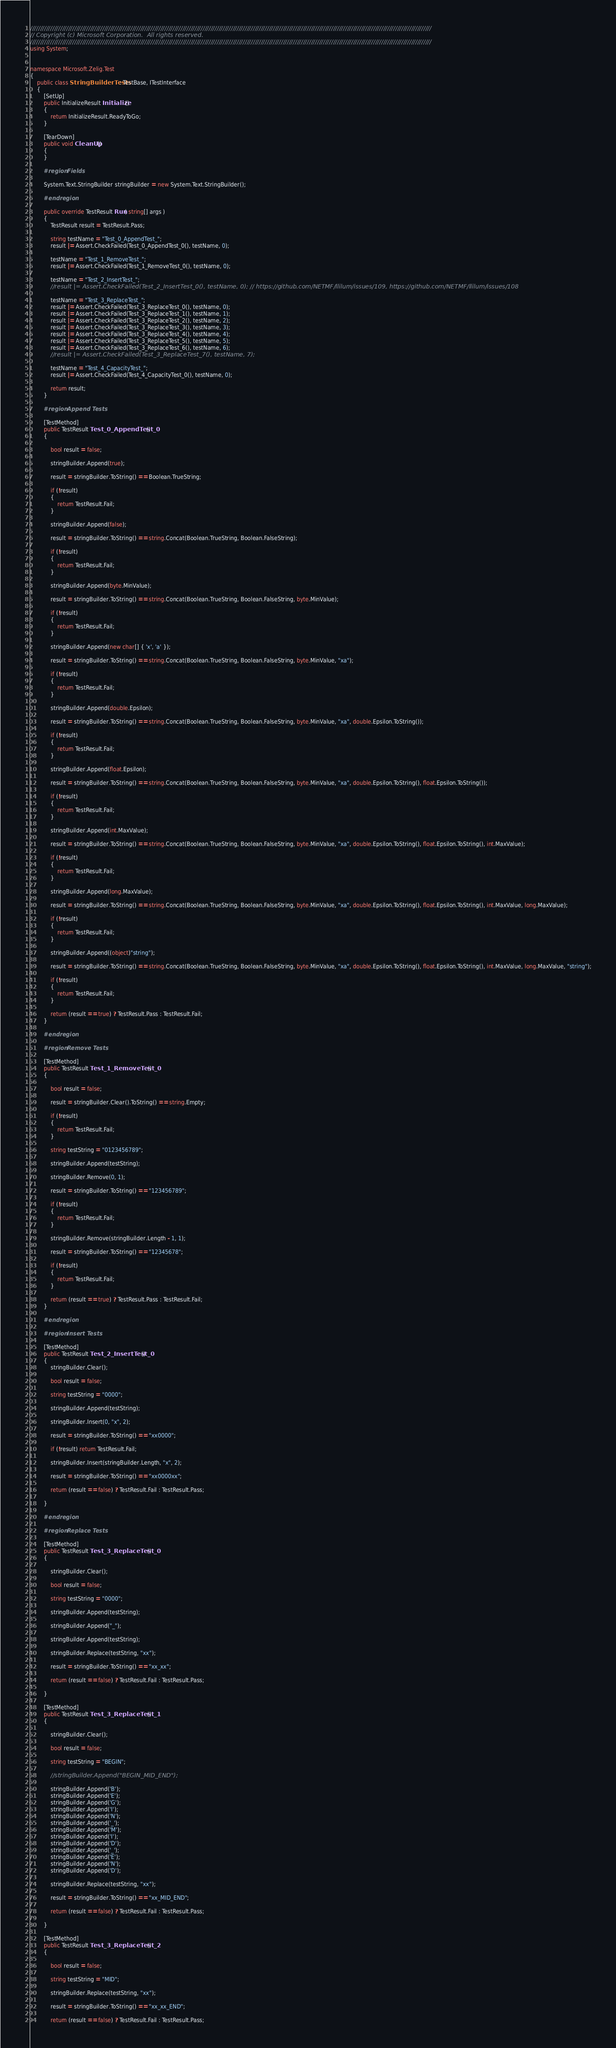<code> <loc_0><loc_0><loc_500><loc_500><_C#_>////////////////////////////////////////////////////////////////////////////////////////////////////////////////////////////////////////////////////////////////////////////////////////////////////////
// Copyright (c) Microsoft Corporation.  All rights reserved.
////////////////////////////////////////////////////////////////////////////////////////////////////////////////////////////////////////////////////////////////////////////////////////////////////////
using System;


namespace Microsoft.Zelig.Test
{
    public class StringBuilderTests : TestBase, ITestInterface
    {
        [SetUp]
        public InitializeResult Initialize()
        {
            return InitializeResult.ReadyToGo;                
        }

        [TearDown]
        public void CleanUp()
        {
        }

        #region Fields

        System.Text.StringBuilder stringBuilder = new System.Text.StringBuilder();

        #endregion

        public override TestResult Run( string[] args )
        {
            TestResult result = TestResult.Pass;

            string testName = "Test_0_AppendTest_";
            result |= Assert.CheckFailed(Test_0_AppendTest_0(), testName, 0);

            testName = "Test_1_RemoveTest_";
            result |= Assert.CheckFailed(Test_1_RemoveTest_0(), testName, 0);

            testName = "Test_2_InsertTest_";
            //result |= Assert.CheckFailed(Test_2_InsertTest_0(), testName, 0); // https://github.com/NETMF/llilum/issues/109, https://github.com/NETMF/llilum/issues/108

            testName = "Test_3_ReplaceTest_";
            result |= Assert.CheckFailed(Test_3_ReplaceTest_0(), testName, 0);
            result |= Assert.CheckFailed(Test_3_ReplaceTest_1(), testName, 1);
            result |= Assert.CheckFailed(Test_3_ReplaceTest_2(), testName, 2);
            result |= Assert.CheckFailed(Test_3_ReplaceTest_3(), testName, 3);
            result |= Assert.CheckFailed(Test_3_ReplaceTest_4(), testName, 4);
            result |= Assert.CheckFailed(Test_3_ReplaceTest_5(), testName, 5);
            result |= Assert.CheckFailed(Test_3_ReplaceTest_6(), testName, 6);
            //result |= Assert.CheckFailed(Test_3_ReplaceTest_7(), testName, 7);

            testName = "Test_4_CapacityTest_";
            result |= Assert.CheckFailed(Test_4_CapacityTest_0(), testName, 0);

            return result;
        }

        #region Append Tests
        
        [TestMethod]
        public TestResult Test_0_AppendTest_0()
        {

            bool result = false;

            stringBuilder.Append(true);

            result = stringBuilder.ToString() == Boolean.TrueString;

            if (!result)
            {
                return TestResult.Fail;
            }

            stringBuilder.Append(false);

            result = stringBuilder.ToString() == string.Concat(Boolean.TrueString, Boolean.FalseString);

            if (!result)
            {
                return TestResult.Fail;
            }

            stringBuilder.Append(byte.MinValue);

            result = stringBuilder.ToString() == string.Concat(Boolean.TrueString, Boolean.FalseString, byte.MinValue);

            if (!result)
            {
                return TestResult.Fail;
            }

            stringBuilder.Append(new char[] { 'x', 'a' });

            result = stringBuilder.ToString() == string.Concat(Boolean.TrueString, Boolean.FalseString, byte.MinValue, "xa");

            if (!result)
            {
                return TestResult.Fail;
            }

            stringBuilder.Append(double.Epsilon);

            result = stringBuilder.ToString() == string.Concat(Boolean.TrueString, Boolean.FalseString, byte.MinValue, "xa", double.Epsilon.ToString());

            if (!result)
            {
                return TestResult.Fail;
            }

            stringBuilder.Append(float.Epsilon);

            result = stringBuilder.ToString() == string.Concat(Boolean.TrueString, Boolean.FalseString, byte.MinValue, "xa", double.Epsilon.ToString(), float.Epsilon.ToString());

            if (!result)
            {
                return TestResult.Fail;
            }

            stringBuilder.Append(int.MaxValue);

            result = stringBuilder.ToString() == string.Concat(Boolean.TrueString, Boolean.FalseString, byte.MinValue, "xa", double.Epsilon.ToString(), float.Epsilon.ToString(), int.MaxValue);

            if (!result)
            {
                return TestResult.Fail;
            }

            stringBuilder.Append(long.MaxValue);

            result = stringBuilder.ToString() == string.Concat(Boolean.TrueString, Boolean.FalseString, byte.MinValue, "xa", double.Epsilon.ToString(), float.Epsilon.ToString(), int.MaxValue, long.MaxValue);

            if (!result)
            {
                return TestResult.Fail;
            }

            stringBuilder.Append((object)"string");

            result = stringBuilder.ToString() == string.Concat(Boolean.TrueString, Boolean.FalseString, byte.MinValue, "xa", double.Epsilon.ToString(), float.Epsilon.ToString(), int.MaxValue, long.MaxValue, "string");

            if (!result)
            {
                return TestResult.Fail;
            }

            return (result == true) ? TestResult.Pass : TestResult.Fail;
        }

        #endregion

        #region Remove Tests

        [TestMethod]
        public TestResult Test_1_RemoveTest_0()
        {

            bool result = false;

            result = stringBuilder.Clear().ToString() == string.Empty;

            if (!result)
            {
                return TestResult.Fail;
            }

            string testString = "0123456789";

            stringBuilder.Append(testString);

            stringBuilder.Remove(0, 1);

            result = stringBuilder.ToString() == "123456789";

            if (!result)
            {
                return TestResult.Fail;
            }

            stringBuilder.Remove(stringBuilder.Length - 1, 1);

            result = stringBuilder.ToString() == "12345678";

            if (!result)
            {
                return TestResult.Fail;
            }

            return (result == true) ? TestResult.Pass : TestResult.Fail;
        }

        #endregion

        #region Insert Tests

        [TestMethod]
        public TestResult Test_2_InsertTest_0()
        {
            stringBuilder.Clear();

            bool result = false;

            string testString = "0000";

            stringBuilder.Append(testString);

            stringBuilder.Insert(0, "x", 2);

            result = stringBuilder.ToString() == "xx0000";

            if (!result) return TestResult.Fail;

            stringBuilder.Insert(stringBuilder.Length, "x", 2);

            result = stringBuilder.ToString() == "xx0000xx";

            return (result == false) ? TestResult.Fail : TestResult.Pass;

        }

        #endregion

        #region Replace Tests

        [TestMethod]
        public TestResult Test_3_ReplaceTest_0()
        {

            stringBuilder.Clear();

            bool result = false;

            string testString = "0000";

            stringBuilder.Append(testString);

            stringBuilder.Append("_");

            stringBuilder.Append(testString);

            stringBuilder.Replace(testString, "xx");

            result = stringBuilder.ToString() == "xx_xx";

            return (result == false) ? TestResult.Fail : TestResult.Pass;

        }

        [TestMethod]
        public TestResult Test_3_ReplaceTest_1()
        {

            stringBuilder.Clear();

            bool result = false;

            string testString = "BEGIN";

            //stringBuilder.Append("BEGIN_MID_END");

            stringBuilder.Append('B');
            stringBuilder.Append('E');
            stringBuilder.Append('G');
            stringBuilder.Append('I');
            stringBuilder.Append('N');
            stringBuilder.Append('_');
            stringBuilder.Append('M');
            stringBuilder.Append('I');
            stringBuilder.Append('D');
            stringBuilder.Append('_');
            stringBuilder.Append('E');
            stringBuilder.Append('N');
            stringBuilder.Append('D');

            stringBuilder.Replace(testString, "xx");

            result = stringBuilder.ToString() == "xx_MID_END";

            return (result == false) ? TestResult.Fail : TestResult.Pass;

        }

        [TestMethod]
        public TestResult Test_3_ReplaceTest_2()
        {

            bool result = false;

            string testString = "MID";

            stringBuilder.Replace(testString, "xx");

            result = stringBuilder.ToString() == "xx_xx_END";

            return (result == false) ? TestResult.Fail : TestResult.Pass;
</code> 